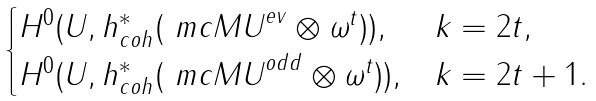<formula> <loc_0><loc_0><loc_500><loc_500>\begin{cases} H ^ { 0 } ( U , h _ { c o h } ^ { * } ( \ m c { M U } ^ { e v } \otimes \omega ^ { t } ) ) , & k = 2 t , \\ H ^ { 0 } ( U , h _ { c o h } ^ { * } ( \ m c { M U } ^ { o d d } \otimes \omega ^ { t } ) ) , & k = 2 t + 1 . \\ \end{cases}</formula> 